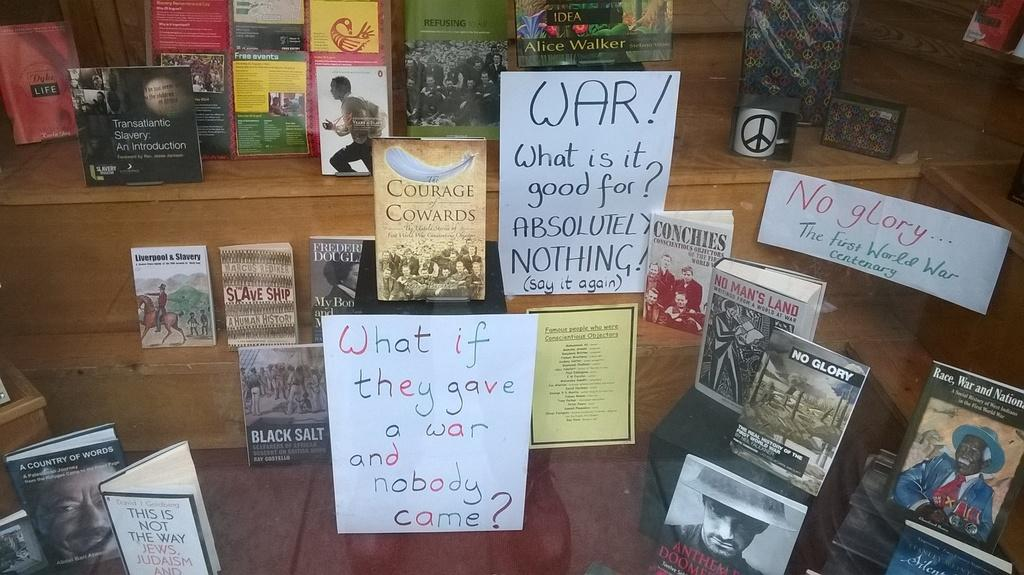<image>
Create a compact narrative representing the image presented. A display of books which includes a sign about war, asking what is it good for, as well as what if they gave a war and nobody came. 